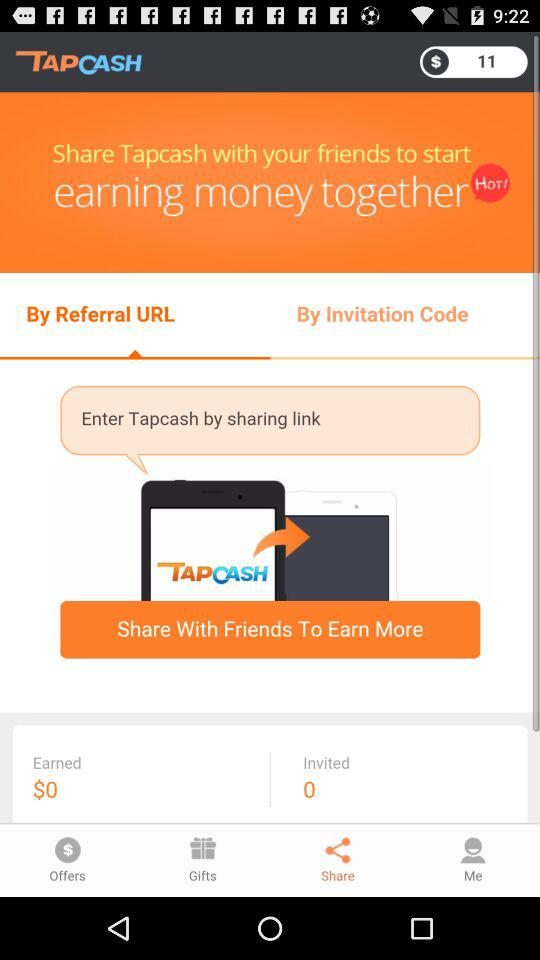What is the name of the application? The name of the application is "Tap Cash Rewards - Make Money". 